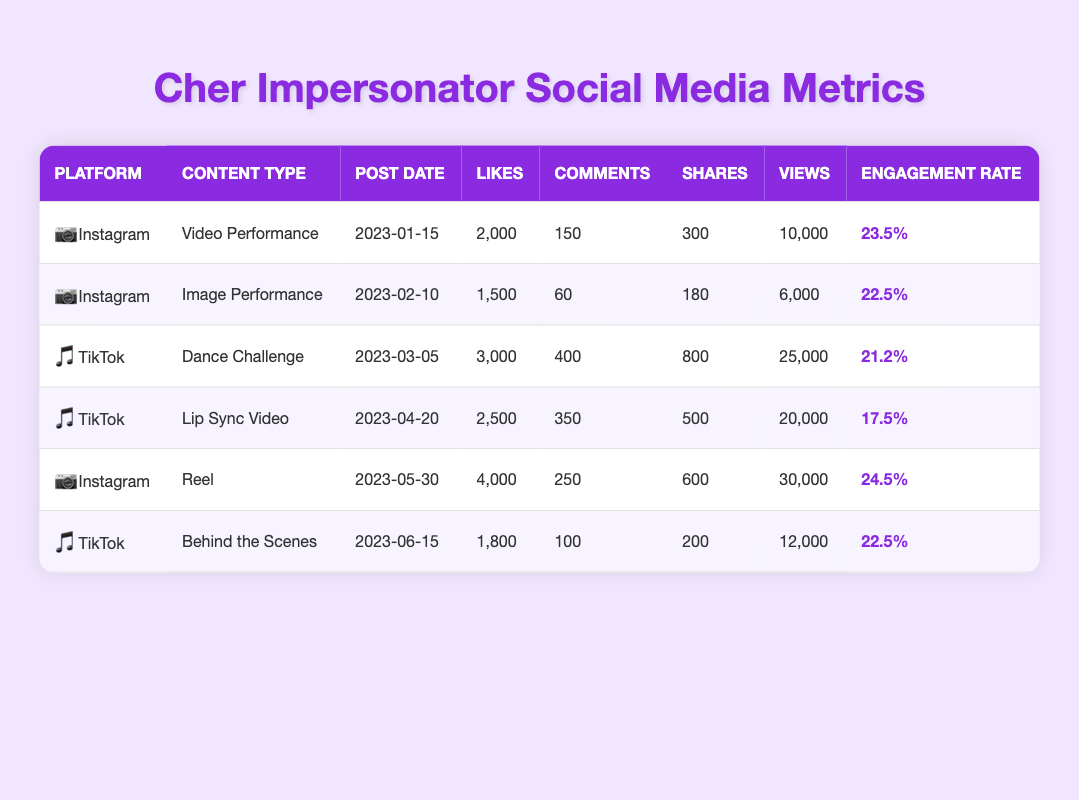What is the highest engagement rate for Cher impersonation content on Instagram? The engagement rates for Instagram content types are 23.5%, 22.5%, and 24.5%. The highest among these is 24.5% from the Reel posted on 2023-05-30.
Answer: 24.5% How many likes did the TikTok Lip Sync Video receive? Referring to the TikTok section, the Lip Sync Video has 2,500 likes recorded on the post date of 2023-04-20.
Answer: 2500 What is the total number of views for all Instagram posts listed? The views for Instagram posts are 10,000 (Video Performance) + 6,000 (Image Performance) + 30,000 (Reel) = 46,000. Thus, the total number of views for Instagram posts is 46,000.
Answer: 46000 Which content type had the most shares on TikTok? The Dance Challenge received 800 shares, while the Lip Sync Video received 500 shares, and the Behind the Scenes received 200 shares. The Dance Challenge has the highest number of shares among them.
Answer: Dance Challenge Is the engagement rate for the Behind the Scenes content on TikTok higher than that for the Image Performance on Instagram? Behind the Scenes has an engagement rate of 22.5%, while Image Performance has an engagement rate of 22.5% as well. Since they are equal, the answer is no.
Answer: No What is the average number of comments across all posts listed in the table? The total comments are 150 (Instagram - Video) + 60 (Instagram - Image) + 400 (TikTok - Dance Challenge) + 350 (TikTok - Lip Sync) + 250 (Instagram - Reel) + 100 (TikTok - Behind the Scenes) = 1,410; there are 6 posts, thus the average is 1,410 / 6 = 235.
Answer: 235 Which platform and content type had the highest number of likes? Reviewing the likes, the TikTok Dance Challenge received the highest number of likes with 3,000. Thus, it is the TikTok Dance Challenge that holds this record.
Answer: TikTok Dance Challenge How many shares did the Instagram Reel have? According to the data, the Instagram Reel received 600 shares, which can be directly found in the table.
Answer: 600 